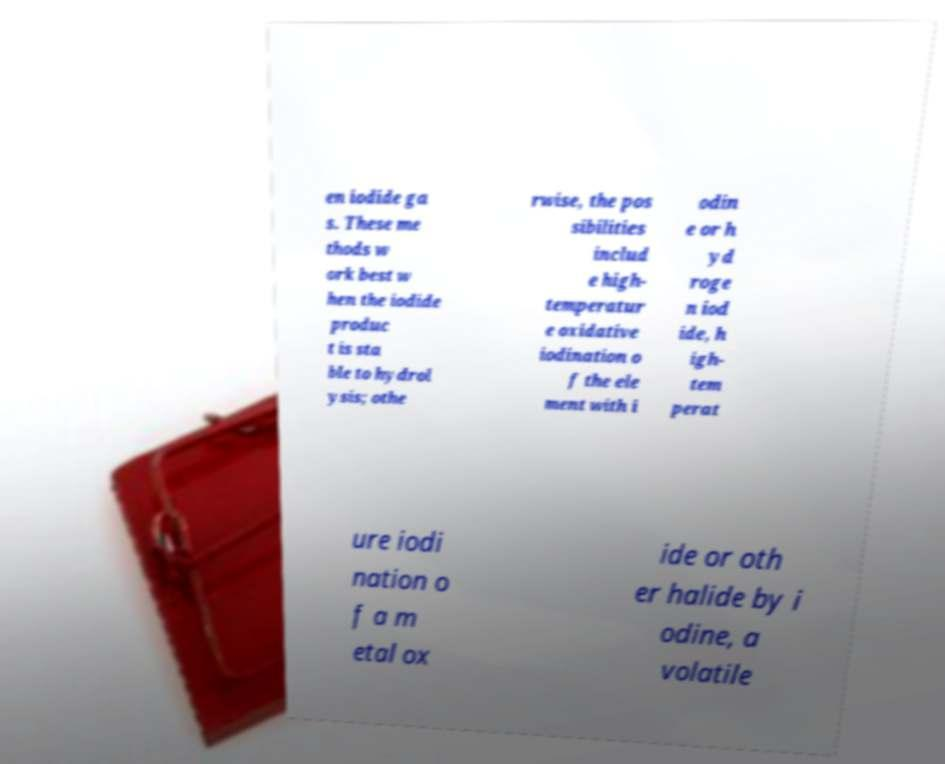Can you read and provide the text displayed in the image?This photo seems to have some interesting text. Can you extract and type it out for me? en iodide ga s. These me thods w ork best w hen the iodide produc t is sta ble to hydrol ysis; othe rwise, the pos sibilities includ e high- temperatur e oxidative iodination o f the ele ment with i odin e or h yd roge n iod ide, h igh- tem perat ure iodi nation o f a m etal ox ide or oth er halide by i odine, a volatile 